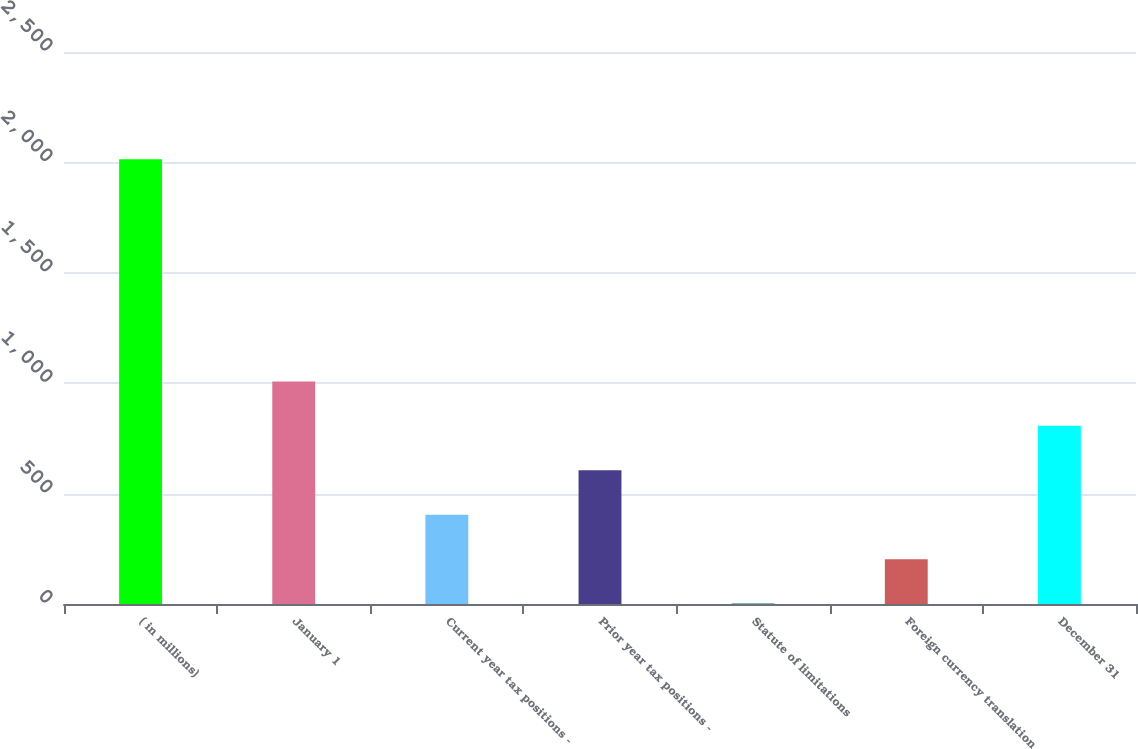<chart> <loc_0><loc_0><loc_500><loc_500><bar_chart><fcel>( in millions)<fcel>January 1<fcel>Current year tax positions -<fcel>Prior year tax positions -<fcel>Statute of limitations<fcel>Foreign currency translation<fcel>December 31<nl><fcel>2014<fcel>1008<fcel>404.4<fcel>605.6<fcel>2<fcel>203.2<fcel>806.8<nl></chart> 